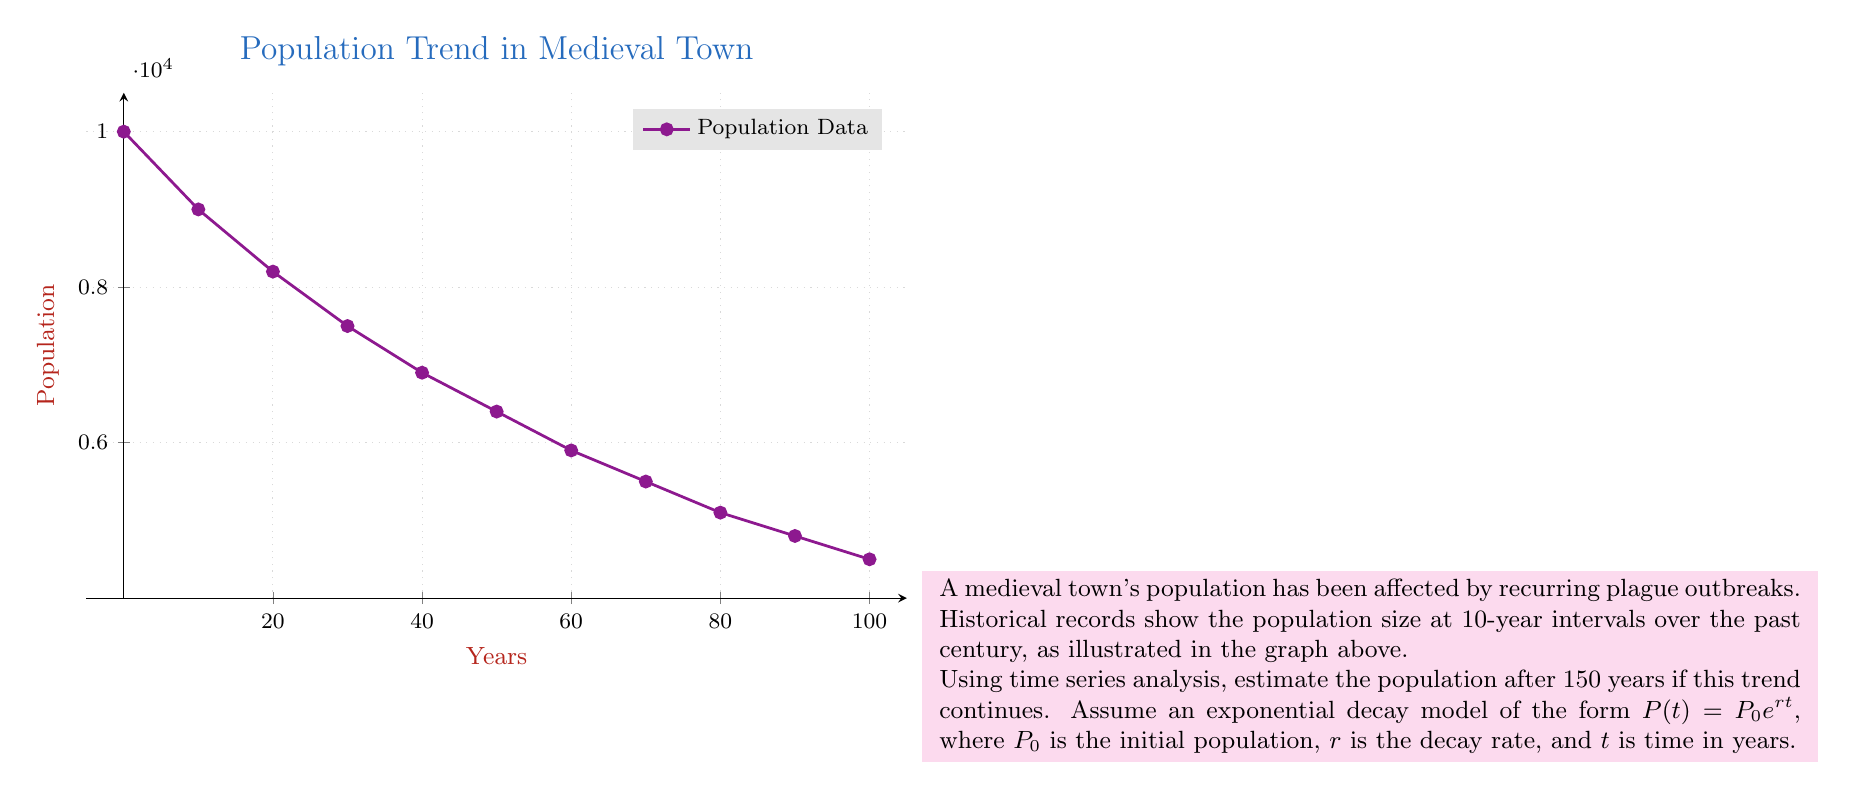Can you solve this math problem? To solve this problem, we'll use the exponential decay model $P(t) = P_0 e^{rt}$ and follow these steps:

1) First, we need to find the decay rate $r$. We can use the initial and final population values:
   $P_0 = 10000$ (at $t=0$)
   $P_{100} = 4500$ (at $t=100$)

2) Plug these into the equation:
   $4500 = 10000 e^{100r}$

3) Solve for $r$:
   $$\begin{align}
   \frac{4500}{10000} &= e^{100r} \\
   \ln(0.45) &= 100r \\
   r &= \frac{\ln(0.45)}{100} \approx -0.007975
   \end{align}$$

4) Now that we have $r$, we can use the model to predict the population at $t=150$ years:
   $$P(150) = 10000 e^{-0.007975 \cdot 150}$$

5) Calculate the result:
   $$\begin{align}
   P(150) &= 10000 e^{-1.19625} \\
   &\approx 10000 \cdot 0.3024 \\
   &\approx 3024
   \end{align}$$

Therefore, the estimated population after 150 years is approximately 3024 people.
Answer: 3024 people 